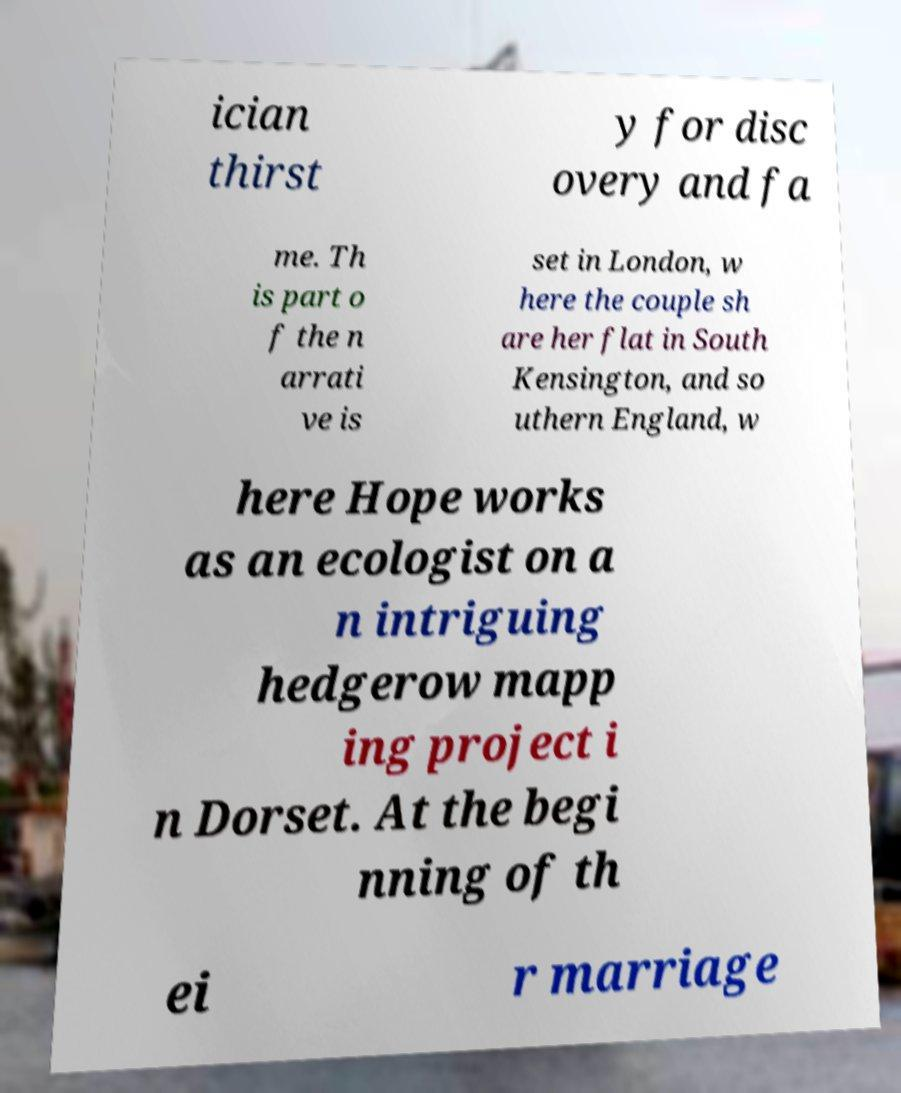For documentation purposes, I need the text within this image transcribed. Could you provide that? ician thirst y for disc overy and fa me. Th is part o f the n arrati ve is set in London, w here the couple sh are her flat in South Kensington, and so uthern England, w here Hope works as an ecologist on a n intriguing hedgerow mapp ing project i n Dorset. At the begi nning of th ei r marriage 